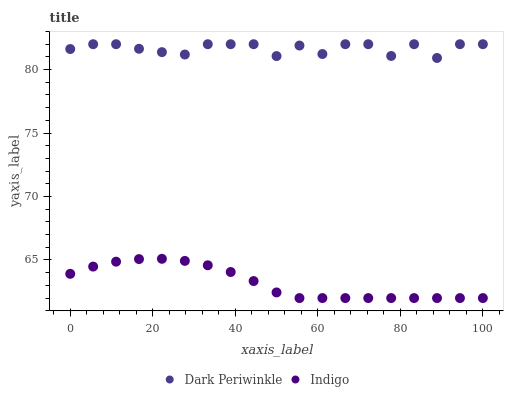Does Indigo have the minimum area under the curve?
Answer yes or no. Yes. Does Dark Periwinkle have the maximum area under the curve?
Answer yes or no. Yes. Does Dark Periwinkle have the minimum area under the curve?
Answer yes or no. No. Is Indigo the smoothest?
Answer yes or no. Yes. Is Dark Periwinkle the roughest?
Answer yes or no. Yes. Is Dark Periwinkle the smoothest?
Answer yes or no. No. Does Indigo have the lowest value?
Answer yes or no. Yes. Does Dark Periwinkle have the lowest value?
Answer yes or no. No. Does Dark Periwinkle have the highest value?
Answer yes or no. Yes. Is Indigo less than Dark Periwinkle?
Answer yes or no. Yes. Is Dark Periwinkle greater than Indigo?
Answer yes or no. Yes. Does Indigo intersect Dark Periwinkle?
Answer yes or no. No. 